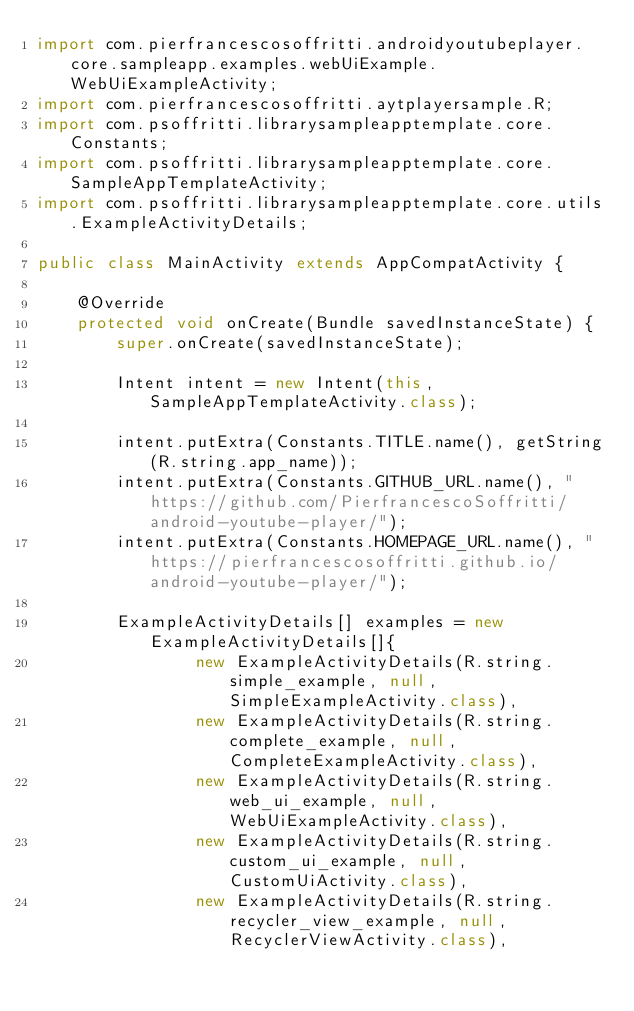<code> <loc_0><loc_0><loc_500><loc_500><_Java_>import com.pierfrancescosoffritti.androidyoutubeplayer.core.sampleapp.examples.webUiExample.WebUiExampleActivity;
import com.pierfrancescosoffritti.aytplayersample.R;
import com.psoffritti.librarysampleapptemplate.core.Constants;
import com.psoffritti.librarysampleapptemplate.core.SampleAppTemplateActivity;
import com.psoffritti.librarysampleapptemplate.core.utils.ExampleActivityDetails;

public class MainActivity extends AppCompatActivity {

    @Override
    protected void onCreate(Bundle savedInstanceState) {
        super.onCreate(savedInstanceState);

        Intent intent = new Intent(this, SampleAppTemplateActivity.class);

        intent.putExtra(Constants.TITLE.name(), getString(R.string.app_name));
        intent.putExtra(Constants.GITHUB_URL.name(), "https://github.com/PierfrancescoSoffritti/android-youtube-player/");
        intent.putExtra(Constants.HOMEPAGE_URL.name(), "https://pierfrancescosoffritti.github.io/android-youtube-player/");

        ExampleActivityDetails[] examples = new ExampleActivityDetails[]{
                new ExampleActivityDetails(R.string.simple_example, null, SimpleExampleActivity.class),
                new ExampleActivityDetails(R.string.complete_example, null, CompleteExampleActivity.class),
                new ExampleActivityDetails(R.string.web_ui_example, null, WebUiExampleActivity.class),
                new ExampleActivityDetails(R.string.custom_ui_example, null, CustomUiActivity.class),
                new ExampleActivityDetails(R.string.recycler_view_example, null, RecyclerViewActivity.class),</code> 